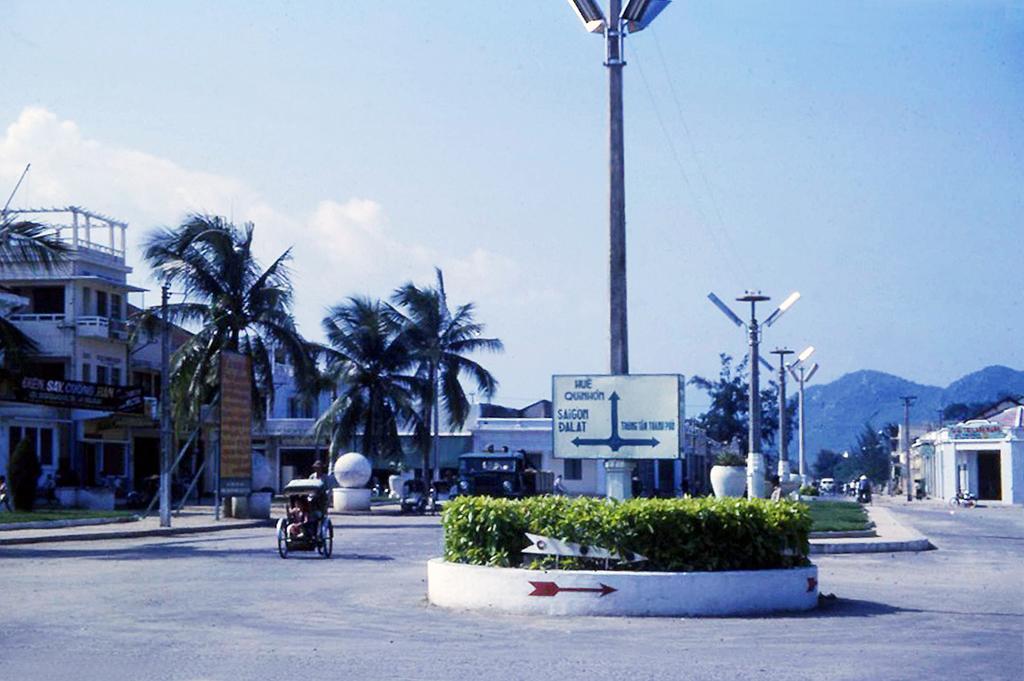In one or two sentences, can you explain what this image depicts? There are roads. On the road there is a cart. There are poles with lights. Also there is a sign board on the pole. There are bushes and grass. In the back there is a vehicle. Also there are trees, buildings. In the background there are hills and sky. 